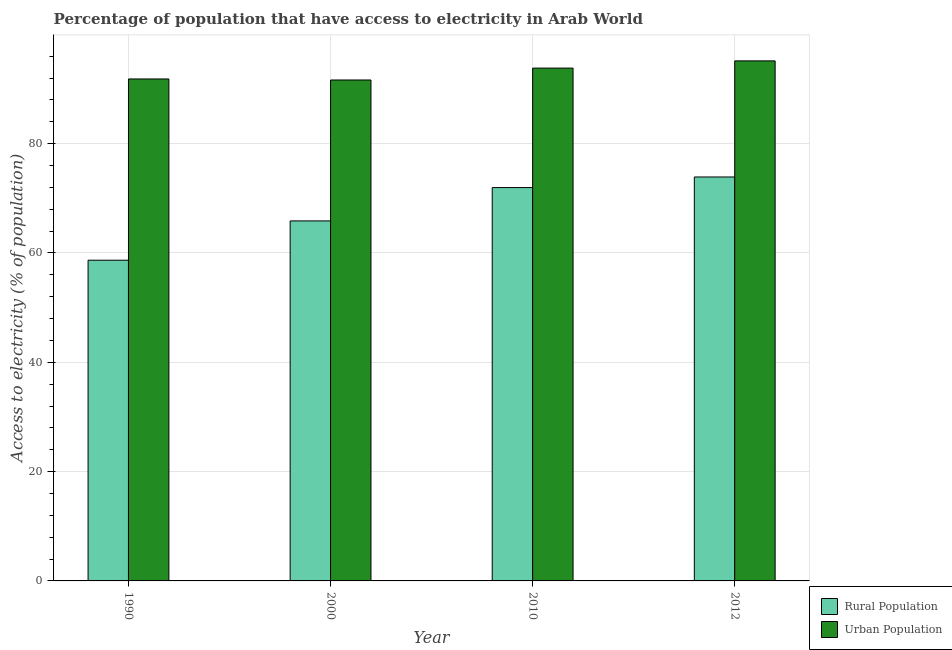How many groups of bars are there?
Keep it short and to the point. 4. How many bars are there on the 1st tick from the right?
Provide a succinct answer. 2. What is the label of the 1st group of bars from the left?
Your response must be concise. 1990. In how many cases, is the number of bars for a given year not equal to the number of legend labels?
Give a very brief answer. 0. What is the percentage of urban population having access to electricity in 1990?
Your answer should be very brief. 91.84. Across all years, what is the maximum percentage of urban population having access to electricity?
Your response must be concise. 95.15. Across all years, what is the minimum percentage of rural population having access to electricity?
Your answer should be very brief. 58.68. What is the total percentage of urban population having access to electricity in the graph?
Your answer should be very brief. 372.48. What is the difference between the percentage of rural population having access to electricity in 1990 and that in 2012?
Provide a short and direct response. -15.23. What is the difference between the percentage of urban population having access to electricity in 1990 and the percentage of rural population having access to electricity in 2012?
Make the answer very short. -3.31. What is the average percentage of rural population having access to electricity per year?
Your answer should be compact. 67.61. In how many years, is the percentage of rural population having access to electricity greater than 48 %?
Offer a terse response. 4. What is the ratio of the percentage of urban population having access to electricity in 2010 to that in 2012?
Offer a terse response. 0.99. What is the difference between the highest and the second highest percentage of rural population having access to electricity?
Your response must be concise. 1.94. What is the difference between the highest and the lowest percentage of urban population having access to electricity?
Your answer should be very brief. 3.5. What does the 2nd bar from the left in 2012 represents?
Your answer should be compact. Urban Population. What does the 1st bar from the right in 1990 represents?
Give a very brief answer. Urban Population. How many bars are there?
Provide a succinct answer. 8. How many years are there in the graph?
Your response must be concise. 4. What is the difference between two consecutive major ticks on the Y-axis?
Give a very brief answer. 20. Are the values on the major ticks of Y-axis written in scientific E-notation?
Provide a short and direct response. No. Does the graph contain grids?
Offer a terse response. Yes. Where does the legend appear in the graph?
Your answer should be very brief. Bottom right. How many legend labels are there?
Your response must be concise. 2. What is the title of the graph?
Provide a short and direct response. Percentage of population that have access to electricity in Arab World. What is the label or title of the X-axis?
Ensure brevity in your answer.  Year. What is the label or title of the Y-axis?
Provide a short and direct response. Access to electricity (% of population). What is the Access to electricity (% of population) in Rural Population in 1990?
Provide a short and direct response. 58.68. What is the Access to electricity (% of population) in Urban Population in 1990?
Your response must be concise. 91.84. What is the Access to electricity (% of population) in Rural Population in 2000?
Your answer should be compact. 65.87. What is the Access to electricity (% of population) of Urban Population in 2000?
Make the answer very short. 91.65. What is the Access to electricity (% of population) in Rural Population in 2010?
Provide a short and direct response. 71.97. What is the Access to electricity (% of population) in Urban Population in 2010?
Offer a very short reply. 93.83. What is the Access to electricity (% of population) of Rural Population in 2012?
Offer a very short reply. 73.91. What is the Access to electricity (% of population) in Urban Population in 2012?
Provide a succinct answer. 95.15. Across all years, what is the maximum Access to electricity (% of population) in Rural Population?
Offer a very short reply. 73.91. Across all years, what is the maximum Access to electricity (% of population) of Urban Population?
Ensure brevity in your answer.  95.15. Across all years, what is the minimum Access to electricity (% of population) in Rural Population?
Your response must be concise. 58.68. Across all years, what is the minimum Access to electricity (% of population) of Urban Population?
Your answer should be compact. 91.65. What is the total Access to electricity (% of population) in Rural Population in the graph?
Offer a very short reply. 270.43. What is the total Access to electricity (% of population) of Urban Population in the graph?
Give a very brief answer. 372.48. What is the difference between the Access to electricity (% of population) of Rural Population in 1990 and that in 2000?
Keep it short and to the point. -7.19. What is the difference between the Access to electricity (% of population) of Urban Population in 1990 and that in 2000?
Offer a terse response. 0.19. What is the difference between the Access to electricity (% of population) of Rural Population in 1990 and that in 2010?
Your response must be concise. -13.29. What is the difference between the Access to electricity (% of population) of Urban Population in 1990 and that in 2010?
Give a very brief answer. -1.99. What is the difference between the Access to electricity (% of population) in Rural Population in 1990 and that in 2012?
Offer a terse response. -15.23. What is the difference between the Access to electricity (% of population) in Urban Population in 1990 and that in 2012?
Your response must be concise. -3.31. What is the difference between the Access to electricity (% of population) in Rural Population in 2000 and that in 2010?
Ensure brevity in your answer.  -6.1. What is the difference between the Access to electricity (% of population) in Urban Population in 2000 and that in 2010?
Your answer should be very brief. -2.17. What is the difference between the Access to electricity (% of population) in Rural Population in 2000 and that in 2012?
Provide a short and direct response. -8.04. What is the difference between the Access to electricity (% of population) in Urban Population in 2000 and that in 2012?
Your response must be concise. -3.5. What is the difference between the Access to electricity (% of population) in Rural Population in 2010 and that in 2012?
Give a very brief answer. -1.94. What is the difference between the Access to electricity (% of population) in Urban Population in 2010 and that in 2012?
Offer a very short reply. -1.32. What is the difference between the Access to electricity (% of population) in Rural Population in 1990 and the Access to electricity (% of population) in Urban Population in 2000?
Offer a very short reply. -32.97. What is the difference between the Access to electricity (% of population) in Rural Population in 1990 and the Access to electricity (% of population) in Urban Population in 2010?
Keep it short and to the point. -35.15. What is the difference between the Access to electricity (% of population) of Rural Population in 1990 and the Access to electricity (% of population) of Urban Population in 2012?
Provide a succinct answer. -36.47. What is the difference between the Access to electricity (% of population) of Rural Population in 2000 and the Access to electricity (% of population) of Urban Population in 2010?
Make the answer very short. -27.96. What is the difference between the Access to electricity (% of population) of Rural Population in 2000 and the Access to electricity (% of population) of Urban Population in 2012?
Make the answer very short. -29.28. What is the difference between the Access to electricity (% of population) in Rural Population in 2010 and the Access to electricity (% of population) in Urban Population in 2012?
Keep it short and to the point. -23.18. What is the average Access to electricity (% of population) of Rural Population per year?
Your answer should be compact. 67.61. What is the average Access to electricity (% of population) of Urban Population per year?
Make the answer very short. 93.12. In the year 1990, what is the difference between the Access to electricity (% of population) in Rural Population and Access to electricity (% of population) in Urban Population?
Provide a succinct answer. -33.16. In the year 2000, what is the difference between the Access to electricity (% of population) in Rural Population and Access to electricity (% of population) in Urban Population?
Give a very brief answer. -25.79. In the year 2010, what is the difference between the Access to electricity (% of population) of Rural Population and Access to electricity (% of population) of Urban Population?
Your answer should be very brief. -21.86. In the year 2012, what is the difference between the Access to electricity (% of population) in Rural Population and Access to electricity (% of population) in Urban Population?
Make the answer very short. -21.24. What is the ratio of the Access to electricity (% of population) in Rural Population in 1990 to that in 2000?
Keep it short and to the point. 0.89. What is the ratio of the Access to electricity (% of population) of Urban Population in 1990 to that in 2000?
Offer a terse response. 1. What is the ratio of the Access to electricity (% of population) of Rural Population in 1990 to that in 2010?
Your answer should be very brief. 0.82. What is the ratio of the Access to electricity (% of population) of Urban Population in 1990 to that in 2010?
Your answer should be very brief. 0.98. What is the ratio of the Access to electricity (% of population) in Rural Population in 1990 to that in 2012?
Offer a terse response. 0.79. What is the ratio of the Access to electricity (% of population) of Urban Population in 1990 to that in 2012?
Your answer should be very brief. 0.97. What is the ratio of the Access to electricity (% of population) in Rural Population in 2000 to that in 2010?
Your answer should be compact. 0.92. What is the ratio of the Access to electricity (% of population) of Urban Population in 2000 to that in 2010?
Your answer should be very brief. 0.98. What is the ratio of the Access to electricity (% of population) of Rural Population in 2000 to that in 2012?
Make the answer very short. 0.89. What is the ratio of the Access to electricity (% of population) of Urban Population in 2000 to that in 2012?
Make the answer very short. 0.96. What is the ratio of the Access to electricity (% of population) in Rural Population in 2010 to that in 2012?
Provide a succinct answer. 0.97. What is the ratio of the Access to electricity (% of population) of Urban Population in 2010 to that in 2012?
Keep it short and to the point. 0.99. What is the difference between the highest and the second highest Access to electricity (% of population) of Rural Population?
Offer a terse response. 1.94. What is the difference between the highest and the second highest Access to electricity (% of population) of Urban Population?
Your response must be concise. 1.32. What is the difference between the highest and the lowest Access to electricity (% of population) of Rural Population?
Ensure brevity in your answer.  15.23. What is the difference between the highest and the lowest Access to electricity (% of population) in Urban Population?
Make the answer very short. 3.5. 